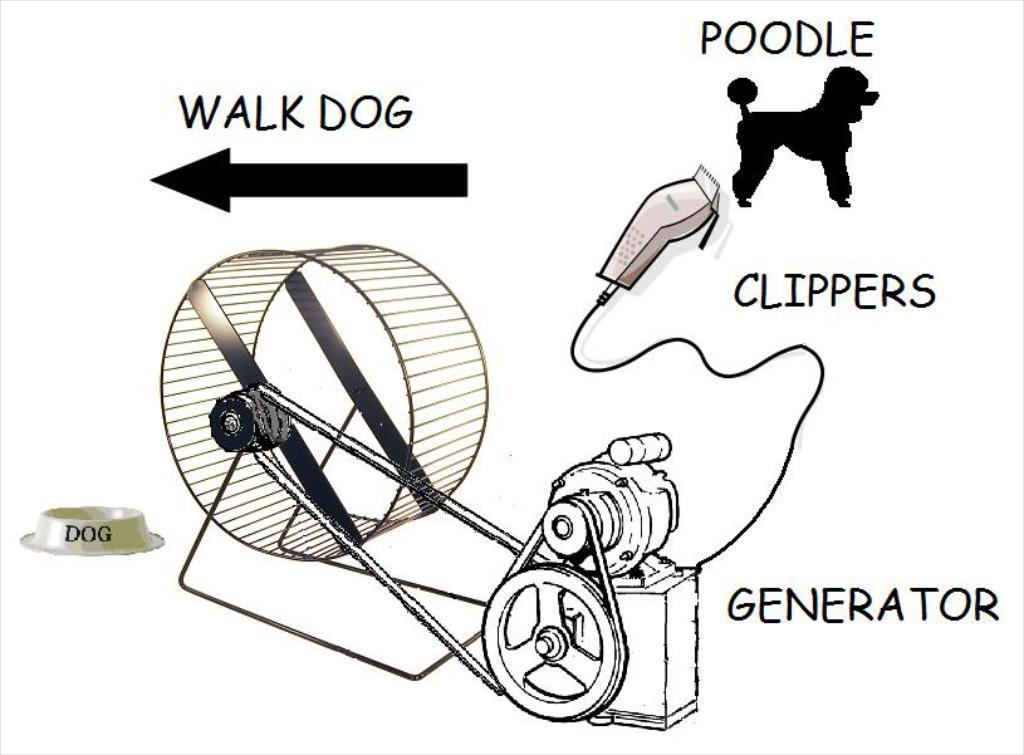What type of machinery is present in the image? There is a generator in the image. What other object can be seen in the image? There is a clipper in the image. What type of drawing is depicted in the image? There is a poodle drawing in the image. What type of credit card is being used to purchase the generator in the image? There is no credit card or purchase activity depicted in the image. 